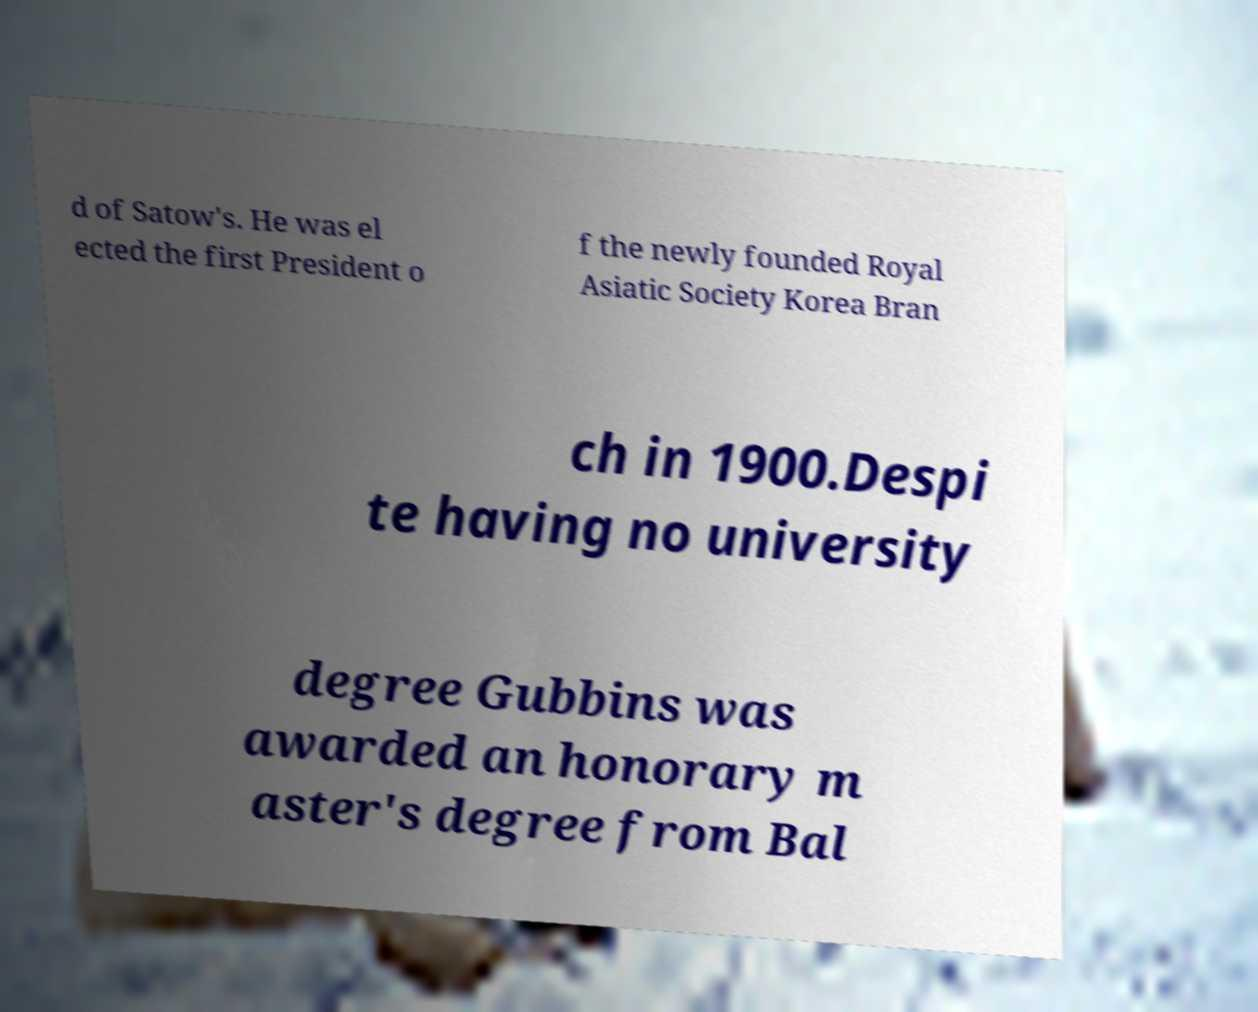Can you accurately transcribe the text from the provided image for me? d of Satow's. He was el ected the first President o f the newly founded Royal Asiatic Society Korea Bran ch in 1900.Despi te having no university degree Gubbins was awarded an honorary m aster's degree from Bal 